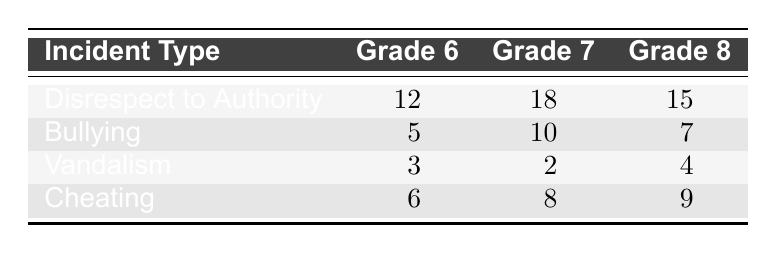What is the total number of incidents for Grade 7? To find the total number of incidents for Grade 7, I need to sum the counts of all incident types for Grade 7: 18 (Disrespect to Authority) + 10 (Bullying) + 2 (Vandalism) + 8 (Cheating) = 38.
Answer: 38 Which incident type has the highest count among Grade 6 students? By comparing the counts for incident types under Grade 6: 12 (Disrespect to Authority), 5 (Bullying), 3 (Vandalism), and 6 (Cheating), I see that 12 is the highest.
Answer: Disrespect to Authority Is there an incident type where Grade 8 students had fewer incidents than Grade 6 students? I will compare the counts for each incident type: Disrespect to Authority (15 vs 12), Bullying (7 vs 5), Vandalism (4 vs 3), and Cheating (9 vs 6). The counts for Bullying and Vandalism show that Grade 8 had more incidents. Therefore, there is none.
Answer: No What is the average number of incidents across all types for Grade 7? First, I will sum the incident counts for Grade 7: 18 (Disrespect to Authority) + 10 (Bullying) + 2 (Vandalism) + 8 (Cheating) = 38. Then I divide by 4 (the number of incident types): 38/4 = 9.5.
Answer: 9.5 How many more incidents of Cheating were reported in Grade 8 than in Grade 6? The count of Cheating incidents for Grade 8 is 9 and for Grade 6 is 6. To find the difference, I subtract: 9 - 6 = 3.
Answer: 3 What is the total count of Vandalism incidents across all grades? I will sum the counts of Vandalism for all grades: 3 (Grade 6) + 2 (Grade 7) + 4 (Grade 8) = 9.
Answer: 9 Is the total number of Disrespect to Authority incidents greater than that of Cheating incidents in Grade 6? I find the counts: Disrespect to Authority in Grade 6 is 12, and Cheating in Grade 6 is 6. Comparing these numbers, 12 is greater than 6.
Answer: Yes Which incident type had the least number of occurrences in Grade 7? For Grade 7, the counts of incidents are: 18 (Disrespect to Authority), 10 (Bullying), 2 (Vandalism), and 8 (Cheating). The least number is 2, corresponding to Vandalism.
Answer: Vandalism 